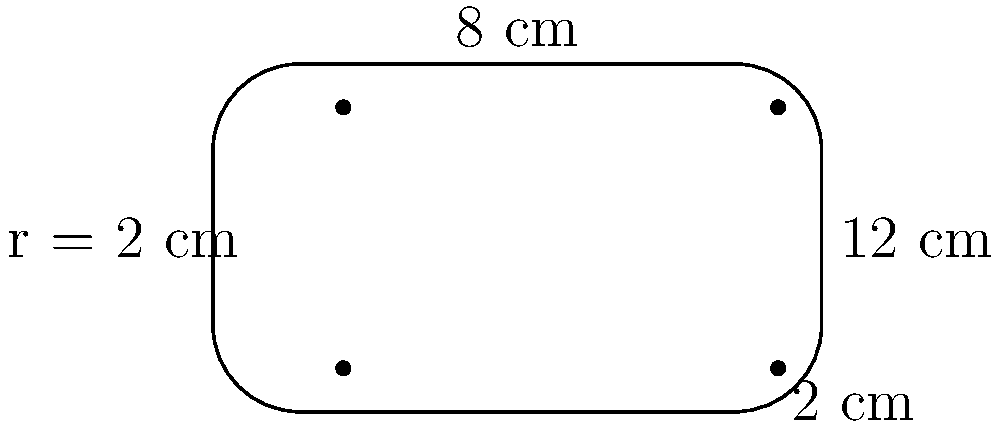Your favorite streamer is showcasing a new gaming keyboard. The keyboard has a rectangular shape with rounded corners, as shown in the diagram. The main body is 12 cm long and 8 cm wide, with corner radii of 2 cm. What is the perimeter of this gaming keyboard? To find the perimeter, we need to calculate the length of the straight edges and the curved corners:

1) Straight edges:
   - Two long sides: $2 \times (12 - 2 - 2) = 16$ cm
   - Two short sides: $2 \times (8 - 2 - 2) = 8$ cm

2) Curved corners:
   - There are four quarter circles, each with a radius of 2 cm
   - The circumference of a full circle is $2\pi r$
   - For four quarter circles: $4 \times \frac{1}{4} \times 2\pi r = \pi r = \pi \times 2 = 2\pi$ cm

3) Total perimeter:
   $\text{Perimeter} = 16 + 8 + 2\pi = 24 + 2\pi$ cm

4) Simplifying:
   $24 + 2\pi \approx 30.28$ cm

Therefore, the perimeter of the gaming keyboard is $24 + 2\pi$ cm or approximately 30.28 cm.
Answer: $24 + 2\pi$ cm 